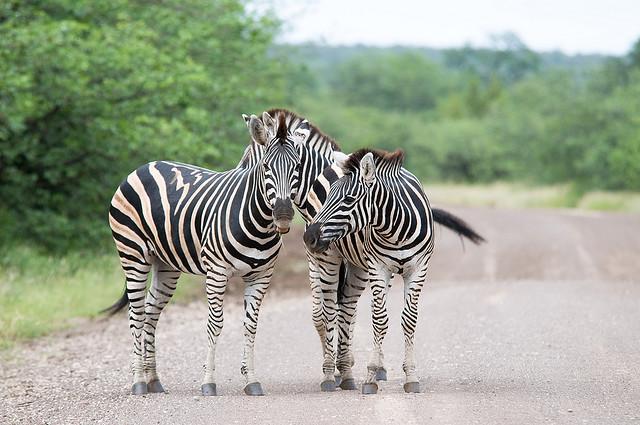Are the animals going for a walk?
Give a very brief answer. Yes. What are the zebras walking on?
Answer briefly. Road. How many striped animals are pictured?
Short answer required. 3. Do the animals look happy?
Answer briefly. Yes. 